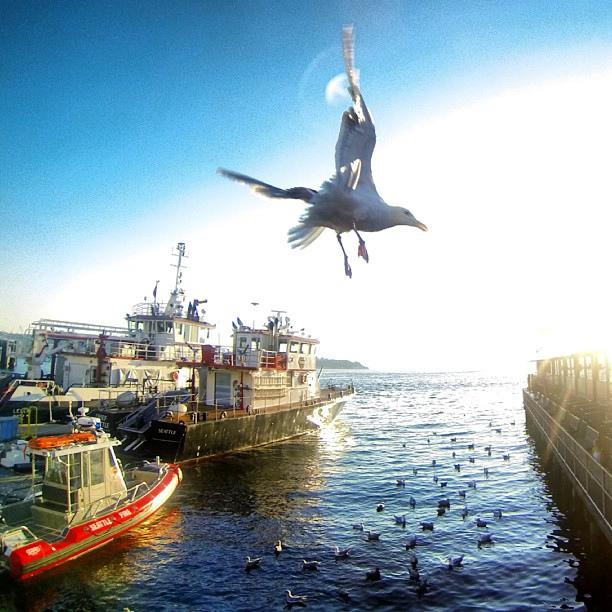Are all of the birds flying?
Concise answer only. No. Is it a cloudy day?
Answer briefly. No. Is the bird flying?
Concise answer only. Yes. 